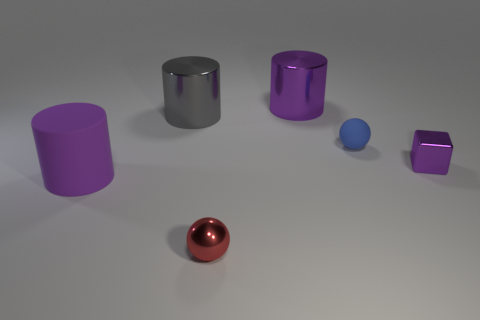Add 4 large purple matte cylinders. How many objects exist? 10 Subtract all large purple matte cylinders. How many cylinders are left? 2 Subtract all blue balls. How many balls are left? 1 Subtract 1 cubes. How many cubes are left? 0 Subtract all big blue matte cylinders. Subtract all large matte cylinders. How many objects are left? 5 Add 5 blue matte spheres. How many blue matte spheres are left? 6 Add 4 red cubes. How many red cubes exist? 4 Subtract 1 blue spheres. How many objects are left? 5 Subtract all blocks. How many objects are left? 5 Subtract all yellow cylinders. Subtract all green cubes. How many cylinders are left? 3 